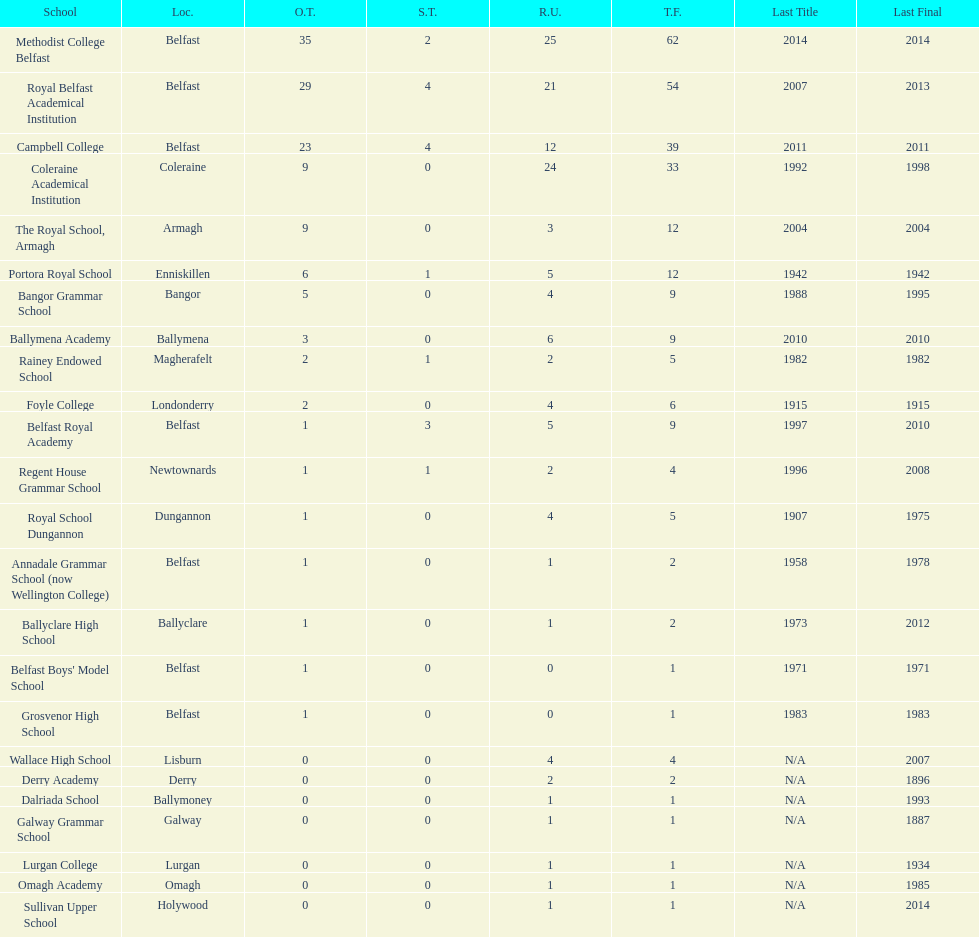Did belfast royal academy have more or less total finals than ballyclare high school? More. 